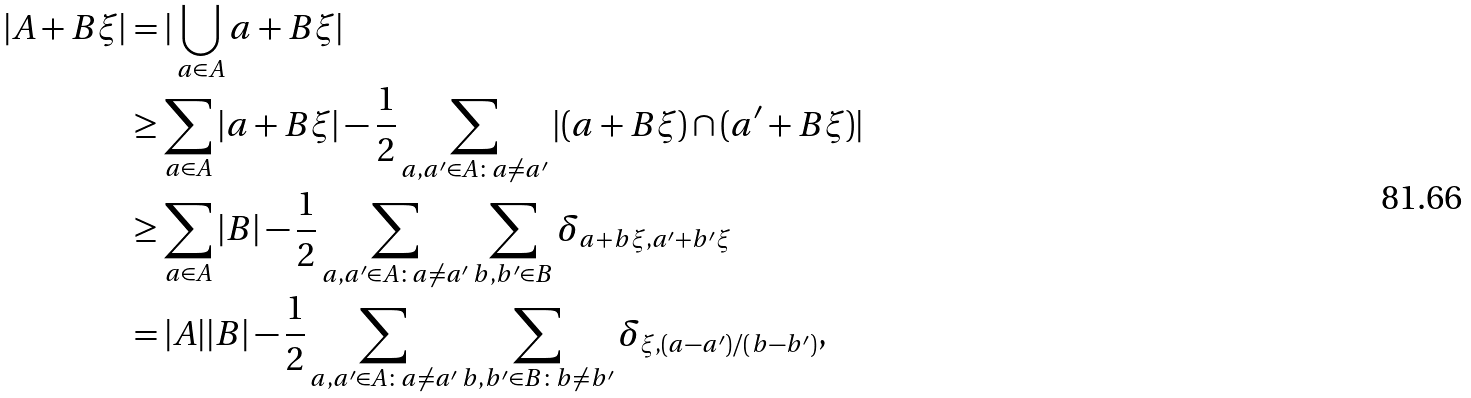<formula> <loc_0><loc_0><loc_500><loc_500>| A + B \xi | & = | \bigcup _ { a \in A } a + B \xi | \\ & \geq \sum _ { a \in A } | a + B \xi | - \frac { 1 } { 2 } \sum _ { a , a ^ { \prime } \in A \colon a \neq a ^ { \prime } } | ( a + B \xi ) \cap ( a ^ { \prime } + B \xi ) | \\ & \geq \sum _ { a \in A } | B | - \frac { 1 } { 2 } \sum _ { a , a ^ { \prime } \in A \colon a \neq a ^ { \prime } } \sum _ { b , b ^ { \prime } \in B } \delta _ { a + b \xi , a ^ { \prime } + b ^ { \prime } \xi } \\ & = | A | | B | - \frac { 1 } { 2 } \sum _ { a , a ^ { \prime } \in A \colon a \neq a ^ { \prime } } \sum _ { b , b ^ { \prime } \in B \colon b \neq b ^ { \prime } } \delta _ { \xi , ( a - a ^ { \prime } ) / ( b - b ^ { \prime } ) } ,</formula> 